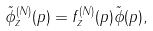<formula> <loc_0><loc_0><loc_500><loc_500>\tilde { \phi } _ { z } ^ { ( N ) } ( p ) = f _ { z } ^ { ( N ) } ( p ) \tilde { \phi } ( p ) ,</formula> 